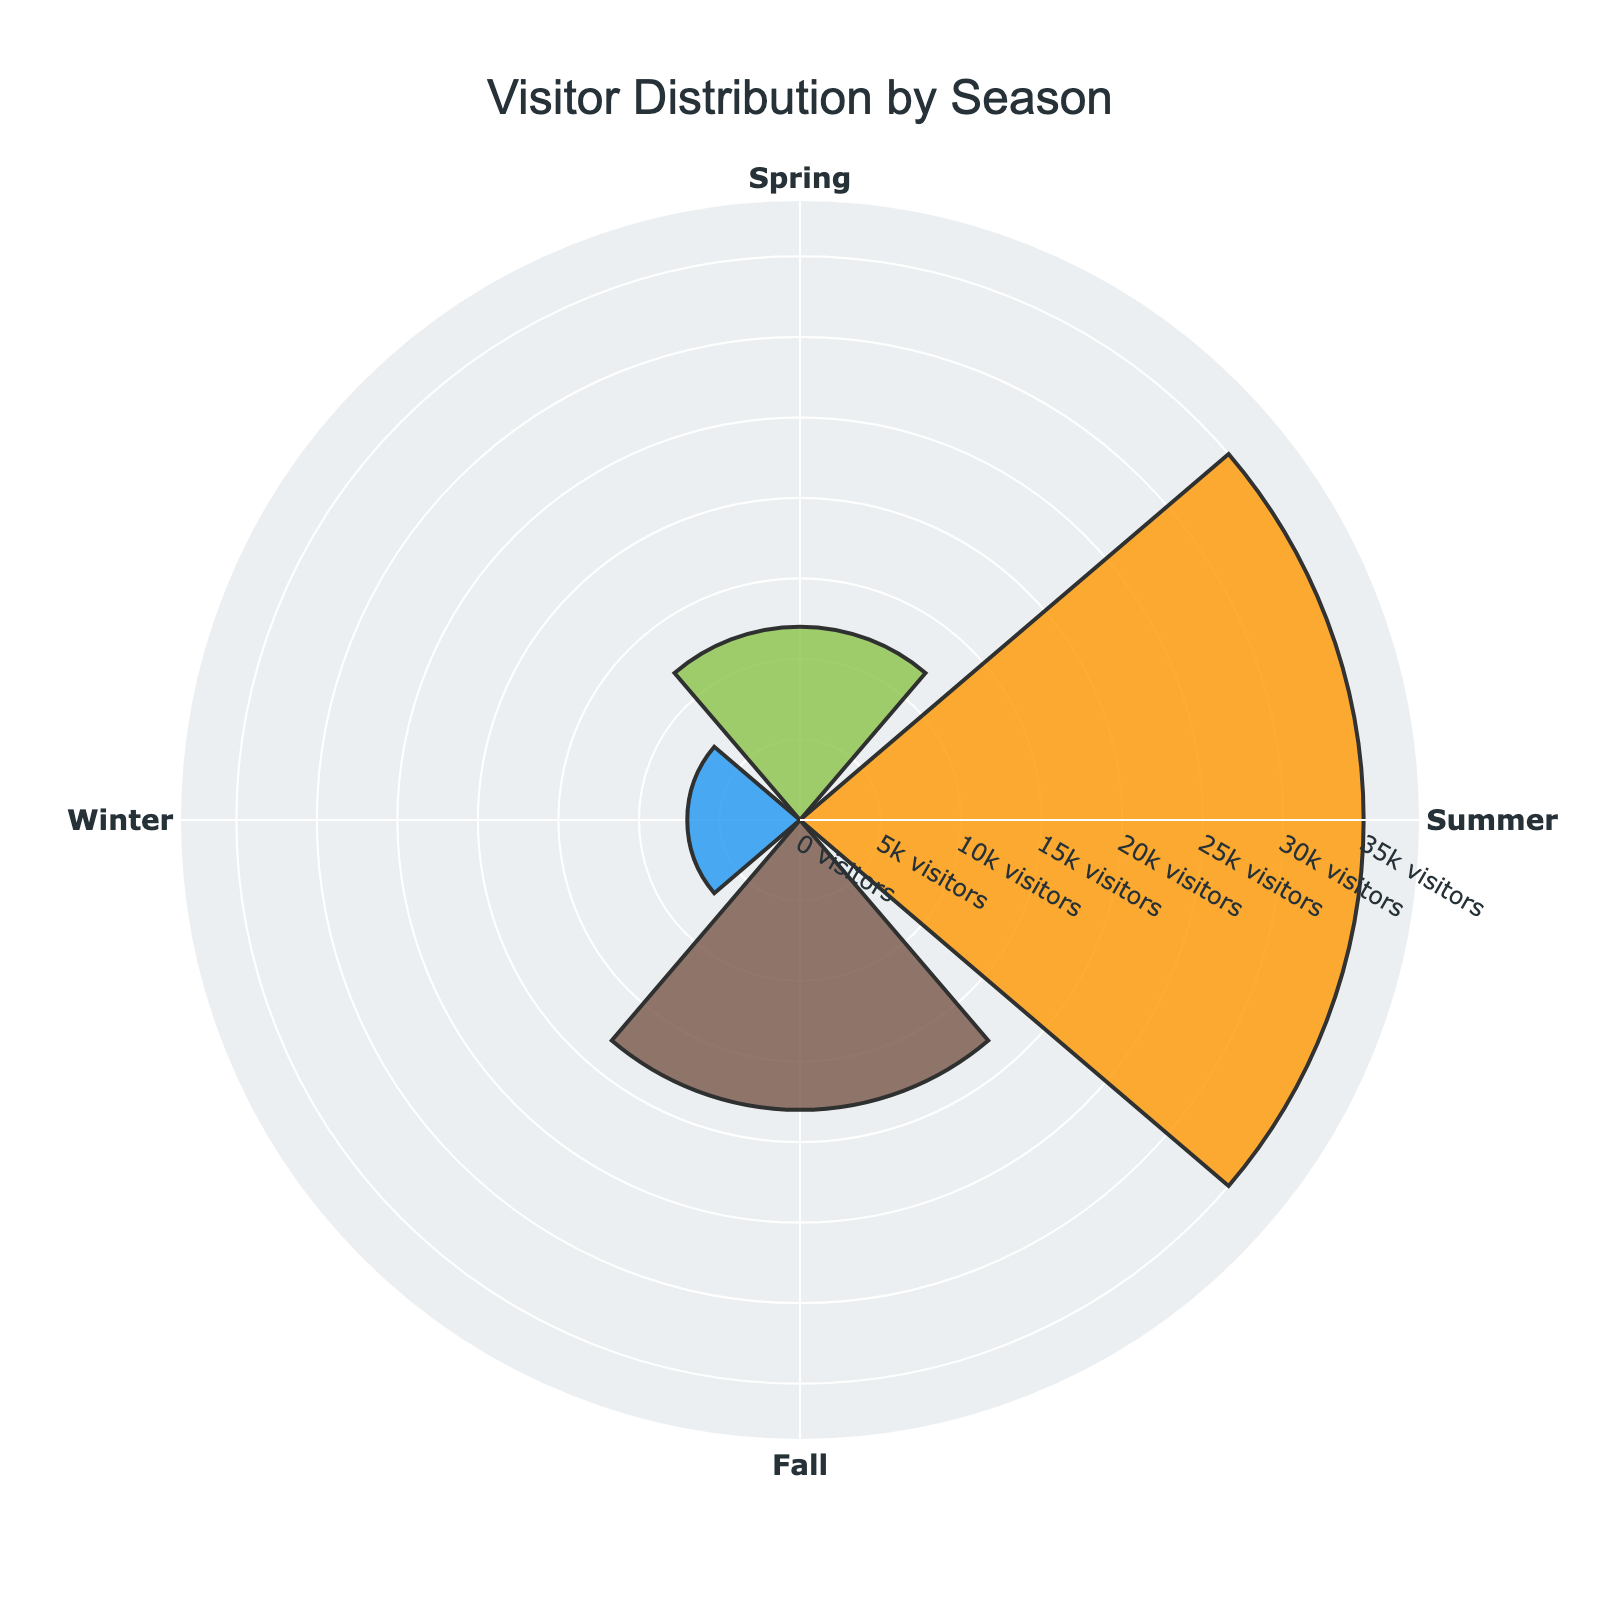What is the title of the plot? The title is usually displayed at the top and summarizes what the plot represents. This helps the viewer quickly understand the context of the plot.
Answer: Visitor Distribution by Season How many visitors were recorded in Winter? Look at the segment labeled "Winter" in the rose chart, which will indicate the number of visitors for that season.
Answer: 7000 Which season recorded the highest number of visitors? Examine the lengths of the bars in the rose chart and identify which one extends the furthest from the center, representing the highest number of visitors.
Answer: Summer What is the total number of visitors in Spring and Fall combined? Sum the number of visitors recorded for Spring and Fall, as indicated in the rose chart data. Spring (12000) + Fall (18000) = 30000
Answer: 30000 How does the number of visitors in Summer compare to the number of visitors in Winter? Subtract the number of Winter visitors from the number of Summer visitors to understand the difference. Summer (35000) - Winter (7000) = 28000
Answer: 28000 Which seasons have more than 15000 visitors? Identify all segments with a visitor count greater than 15000. According to the plot, this would be Spring (12000), Summer (35000), and Fall (18000). Only Summer and Fall meet this criterion.
Answer: Summer and Fall What percent of the total visitors came in Summer? Calculate the total number of visitors across all seasons and find the percentage that corresponds to Summer. Total visitors = 12000 (Spring) + 35000 (Summer) + 18000 (Fall) + 7000 (Winter) = 72000. Summer percent = (35000 / 72000) * 100 ≈ 48.6%.
Answer: 48.6% What is the average number of visitors per season? Calculate the total number of visitors and divide by the number of seasons (4). Total visitors = 72000. Average = 72000 / 4 = 18000.
Answer: 18000 